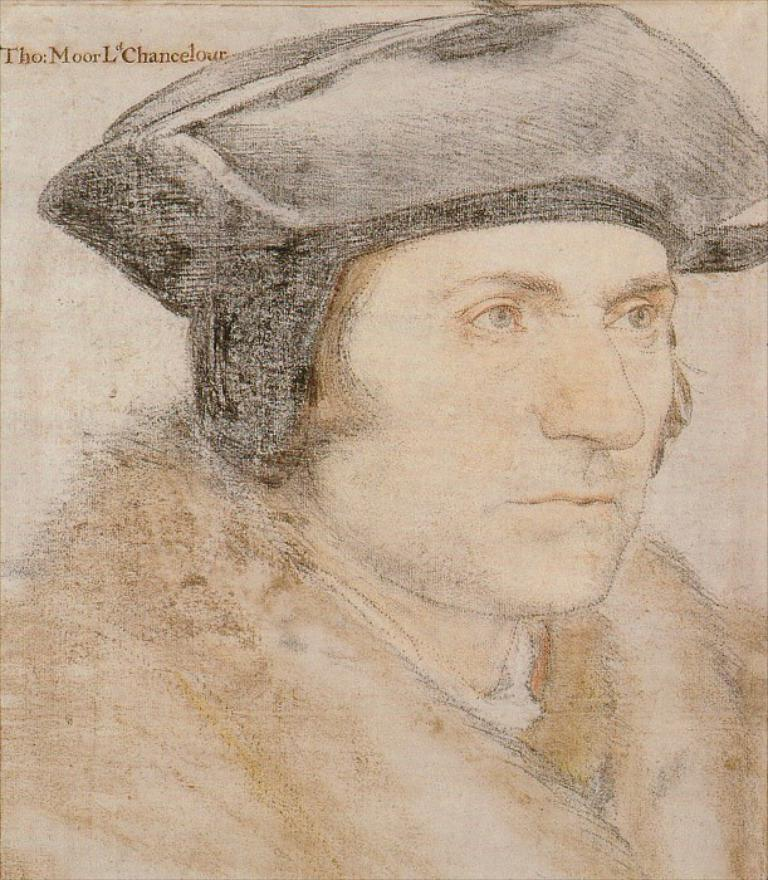What is depicted in the image? There is a sketch of a man in the image. What type of needle is being used in the protest depicted in the image? There is no protest or needle present in the image; it features a sketch of a man. 